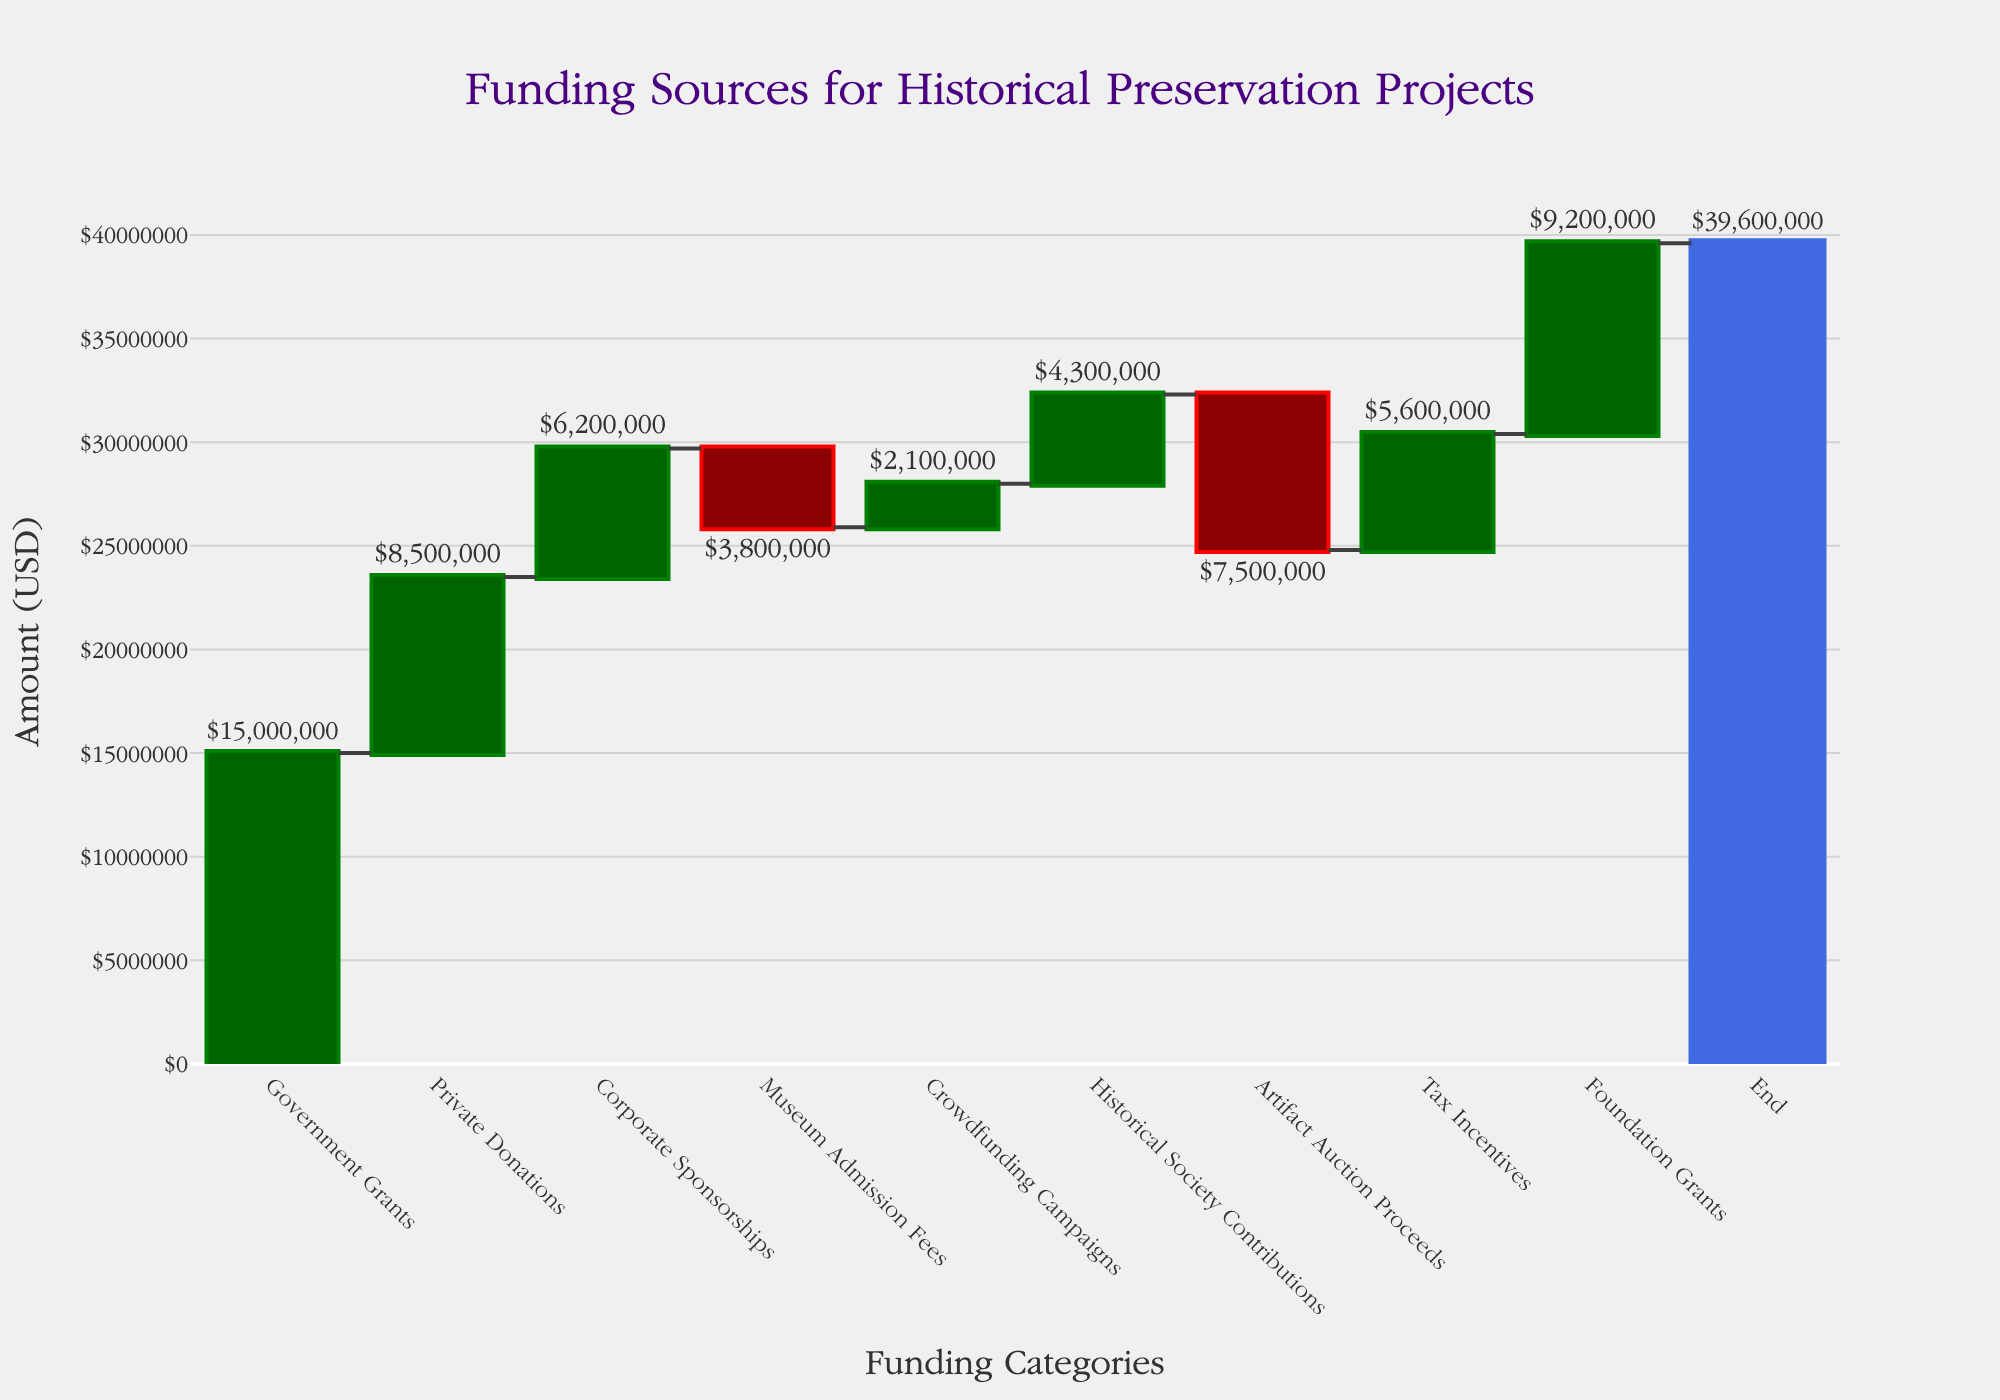What's the total amount of funding from Government Grants? The Government Grants category shows an increase of $15,000,000 in the chart.
Answer: $15,000,000 Which funding source contributes the least to historical preservation projects? The Artifact Auction Proceeds show the largest negative value with a decrease of $7,500,000 in the chart.
Answer: Artifact Auction Proceeds How does the contribution from Private Donations compare to Crowdfunding Campaigns? The Private Donations contribute $8,500,000, while Crowdfunding Campaigns contribute $2,100,000. Thus, Private Donations contribute $6,400,000 more.
Answer: $6,400,000 more What is the net impact of Museum Admission Fees and Artifact Auction Proceeds combined? Museum Admission Fees decrease by $3,800,000 and Artifact Auction Proceeds decrease by $7,500,000. The combined impact is -$3,800,000 - $7,500,000 = -$11,300,000.
Answer: -$11,300,000 What's the difference between the total contributions from Foundation Grants and Corporate Sponsorships? Foundation Grants contribute $9,200,000, while Corporate Sponsorships contribute $6,200,000. The difference is $9,200,000 - $6,200,000 = $3,000,000.
Answer: $3,000,000 What are the total private contributions (Private Donations, Corporate Sponsorships, Crowdfunding Campaigns, Historical Society Contributions, and Foundation Grants)? The contributions are $8,500,000 (Private Donations) + $6,200,000 (Corporate Sponsorships) + $2,100,000 (Crowdfunding Campaigns) + $4,300,000 (Historical Society Contributions) + $9,200,000 (Foundation Grants) = $30,300,000.
Answer: $30,300,000 What's the overall change in funding after accounting for all categories? The starting value is $0, and the ending value is $39,600,000, which indicates the overall change is $39,600,000.
Answer: $39,600,000 How much more does the government contribute compared to historical society contributions? The Government Grants contribute $15,000,000, while Historical Society Contributions provide $4,300,000. The difference is $15,000,000 - $4,300,000 = $10,700,000.
Answer: $10,700,000 What is the ratio of Tax Incentives to Crowdfunding Campaigns? Tax Incentives contribute $5,600,000, while Crowdfunding Campaigns contribute $2,100,000. The ratio is $5,600,000 / $2,100,000 ≈ 2.67.
Answer: 2.67 